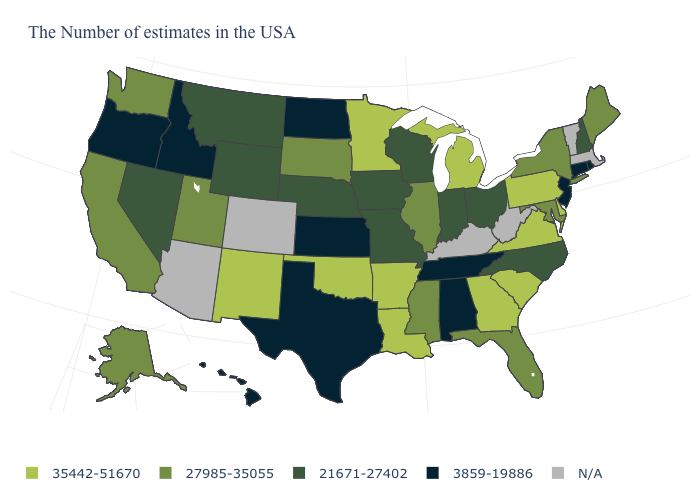Name the states that have a value in the range N/A?
Give a very brief answer. Massachusetts, Vermont, West Virginia, Kentucky, Colorado, Arizona. What is the value of Iowa?
Concise answer only. 21671-27402. What is the value of Minnesota?
Concise answer only. 35442-51670. Is the legend a continuous bar?
Short answer required. No. What is the value of Maine?
Answer briefly. 27985-35055. Name the states that have a value in the range N/A?
Concise answer only. Massachusetts, Vermont, West Virginia, Kentucky, Colorado, Arizona. Name the states that have a value in the range 3859-19886?
Give a very brief answer. Rhode Island, Connecticut, New Jersey, Alabama, Tennessee, Kansas, Texas, North Dakota, Idaho, Oregon, Hawaii. What is the highest value in the MidWest ?
Short answer required. 35442-51670. What is the value of Nevada?
Keep it brief. 21671-27402. Does Maine have the lowest value in the USA?
Be succinct. No. What is the value of Oklahoma?
Answer briefly. 35442-51670. What is the lowest value in the USA?
Concise answer only. 3859-19886. Which states have the highest value in the USA?
Write a very short answer. Delaware, Pennsylvania, Virginia, South Carolina, Georgia, Michigan, Louisiana, Arkansas, Minnesota, Oklahoma, New Mexico. What is the highest value in the South ?
Quick response, please. 35442-51670. 